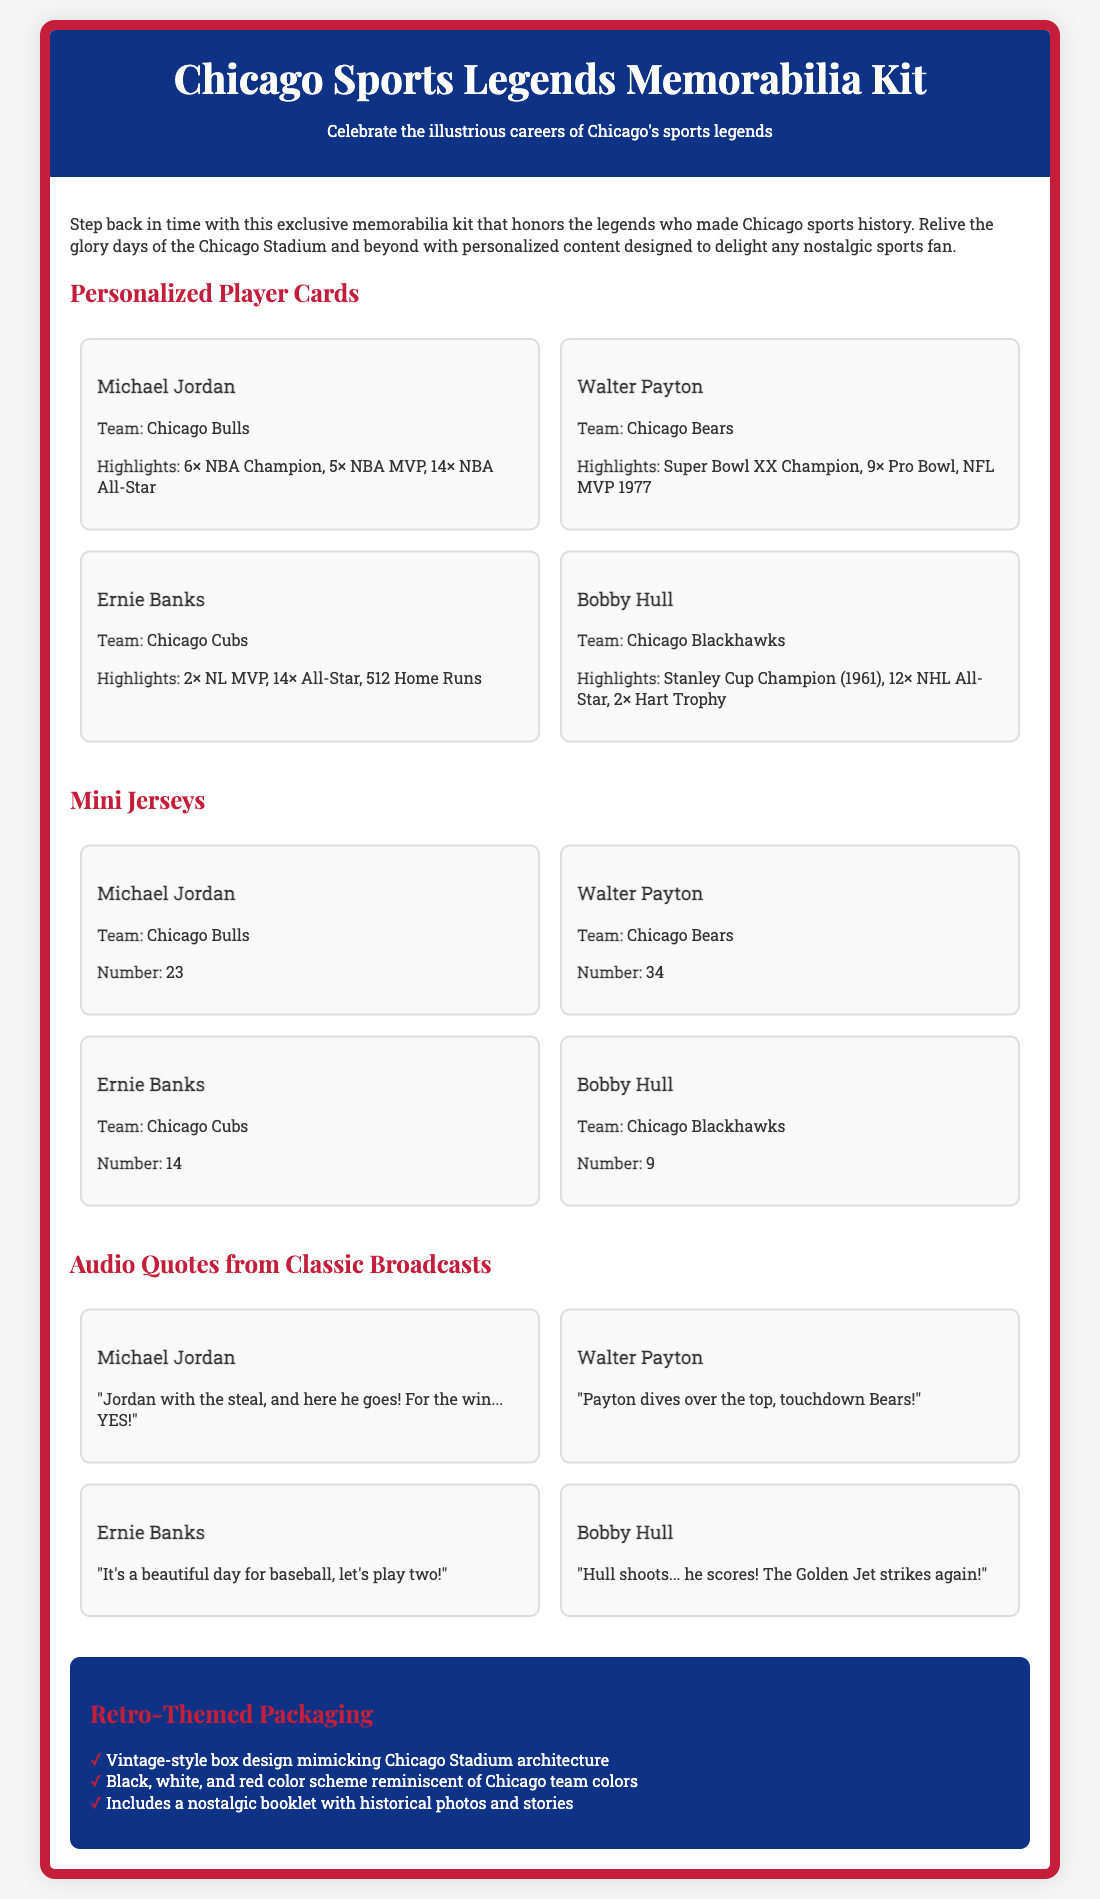what is the title of the memorabilia kit? The title of the memorabilia kit is prominently displayed at the top of the document.
Answer: Chicago Sports Legends Memorabilia Kit how many mini jerseys are included? The document lists four mini jerseys, one for each featured player.
Answer: 4 who is featured on the player card for the Chicago Bears? The player card specifically details the accomplishments and team of the Chicago Bears’ legend.
Answer: Walter Payton which color scheme is used in the packaging? The packaging uses a color scheme that reflects the prominent colors of Chicago teams, as noted in the section about retro-themed packaging.
Answer: Black, white, and red what is one notable quote from Michael Jordan? The document includes a quote attributed to Michael Jordan that captures a memorable moment from a broadcast.
Answer: "Jordan with the steal, and here he goes! For the win... YES!" which team did Ernie Banks play for? The team for which Ernie Banks is prominently noted in the player card section of the document.
Answer: Chicago Cubs what type of packaging is used for the kit? The document defines the design style of the packaging that wraps the memorabilia kit.
Answer: Retro-themed box how many highlights are listed for Bobby Hull? The document states the number of highlights for Bobby Hull in his player card.
Answer: 3 